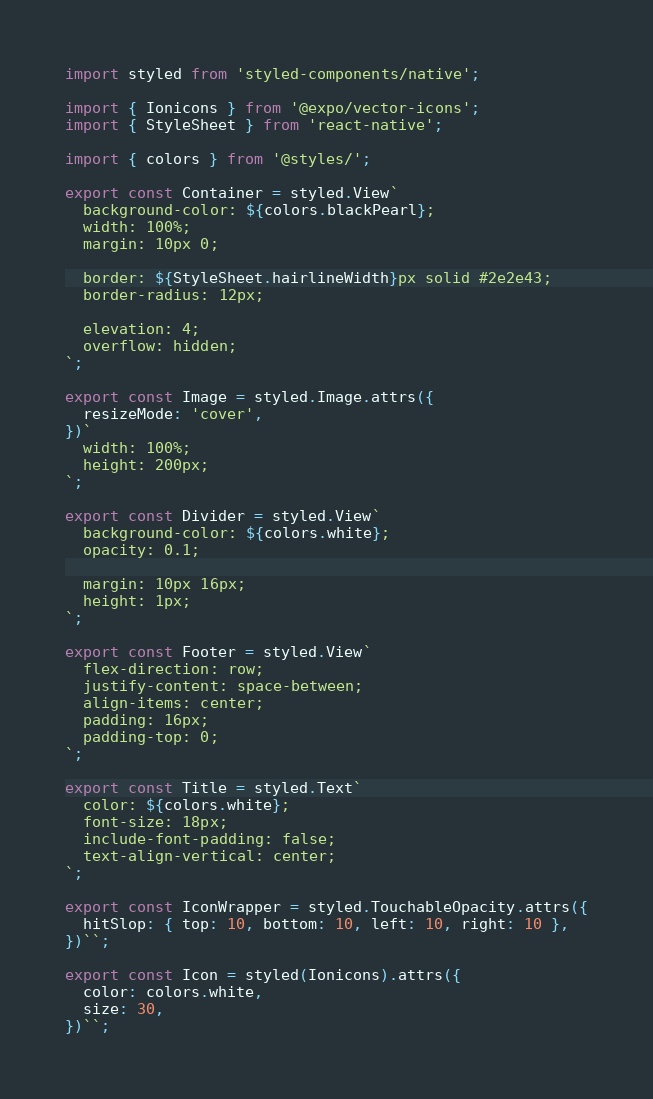<code> <loc_0><loc_0><loc_500><loc_500><_JavaScript_>import styled from 'styled-components/native';

import { Ionicons } from '@expo/vector-icons';
import { StyleSheet } from 'react-native';

import { colors } from '@styles/';

export const Container = styled.View`
  background-color: ${colors.blackPearl};
  width: 100%;
  margin: 10px 0;

  border: ${StyleSheet.hairlineWidth}px solid #2e2e43;
  border-radius: 12px;

  elevation: 4;
  overflow: hidden;
`;

export const Image = styled.Image.attrs({
  resizeMode: 'cover',
})`
  width: 100%;
  height: 200px;
`;

export const Divider = styled.View`
  background-color: ${colors.white};
  opacity: 0.1;

  margin: 10px 16px;
  height: 1px;
`;

export const Footer = styled.View`
  flex-direction: row;
  justify-content: space-between;
  align-items: center;
  padding: 16px;
  padding-top: 0;
`;

export const Title = styled.Text`
  color: ${colors.white};
  font-size: 18px;
  include-font-padding: false;
  text-align-vertical: center;
`;

export const IconWrapper = styled.TouchableOpacity.attrs({
  hitSlop: { top: 10, bottom: 10, left: 10, right: 10 },
})``;

export const Icon = styled(Ionicons).attrs({
  color: colors.white,
  size: 30,
})``;
</code> 